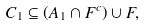<formula> <loc_0><loc_0><loc_500><loc_500>C _ { 1 } \subseteq \left ( A _ { 1 } \cap F ^ { c } \right ) \cup F ,</formula> 